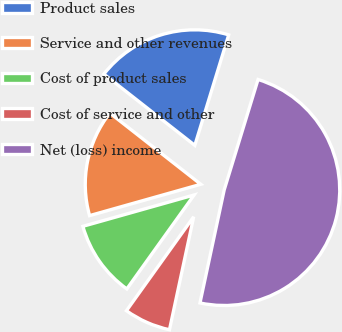Convert chart. <chart><loc_0><loc_0><loc_500><loc_500><pie_chart><fcel>Product sales<fcel>Service and other revenues<fcel>Cost of product sales<fcel>Cost of service and other<fcel>Net (loss) income<nl><fcel>19.16%<fcel>14.95%<fcel>10.74%<fcel>6.53%<fcel>48.63%<nl></chart> 